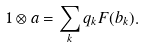Convert formula to latex. <formula><loc_0><loc_0><loc_500><loc_500>1 \otimes a = \sum _ { k } q _ { k } F ( b _ { k } ) .</formula> 